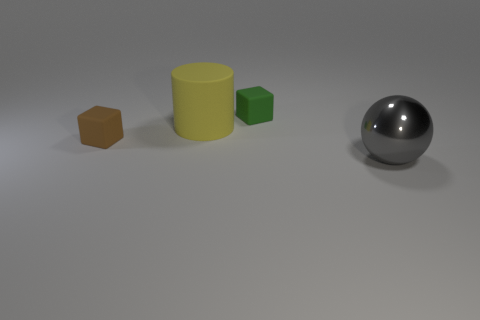Add 2 large brown matte balls. How many objects exist? 6 Subtract all balls. How many objects are left? 3 Add 3 gray metallic objects. How many gray metallic objects exist? 4 Subtract 0 yellow blocks. How many objects are left? 4 Subtract all small brown rubber cubes. Subtract all gray things. How many objects are left? 2 Add 4 large rubber cylinders. How many large rubber cylinders are left? 5 